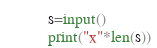<code> <loc_0><loc_0><loc_500><loc_500><_Python_>s=input()
print("x"*len(s))</code> 